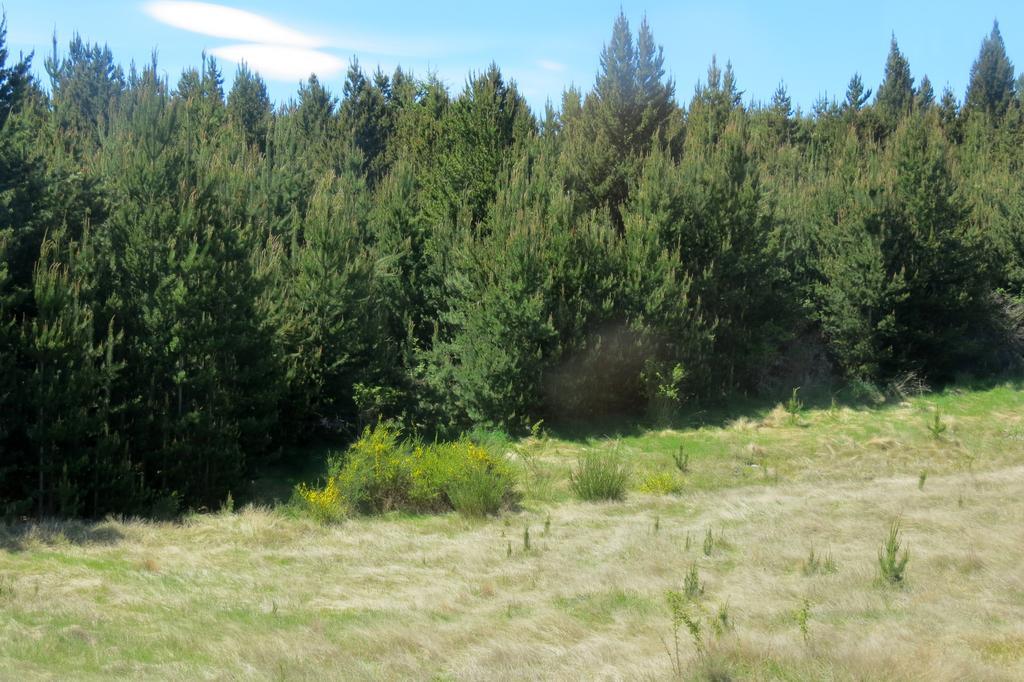Please provide a concise description of this image. In this picture we can see grass, plants and trees. In the background of the image we can see the sky. 